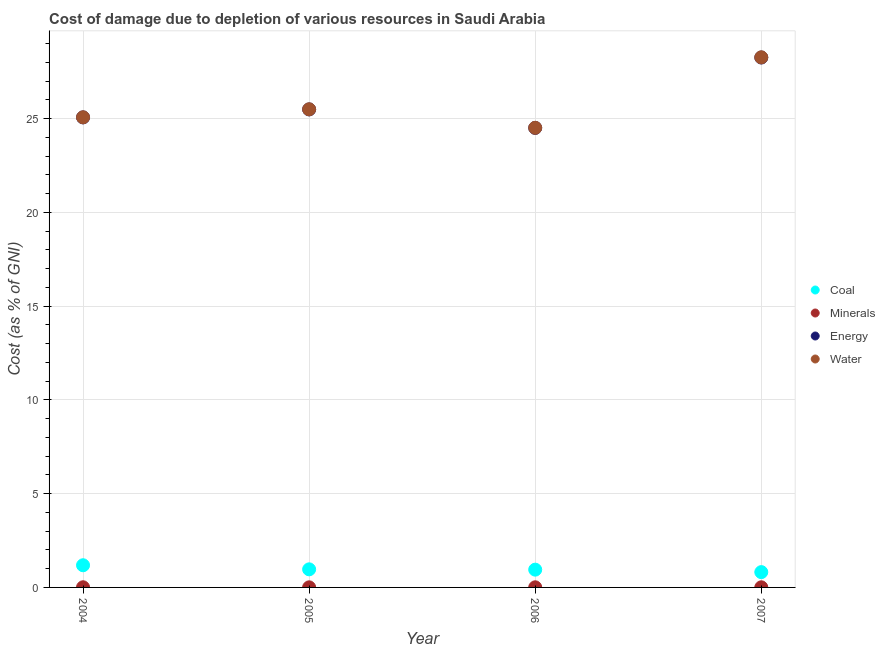How many different coloured dotlines are there?
Your answer should be very brief. 4. What is the cost of damage due to depletion of energy in 2005?
Provide a succinct answer. 25.49. Across all years, what is the maximum cost of damage due to depletion of coal?
Offer a terse response. 1.18. Across all years, what is the minimum cost of damage due to depletion of water?
Make the answer very short. 24.51. What is the total cost of damage due to depletion of minerals in the graph?
Your answer should be very brief. 0.03. What is the difference between the cost of damage due to depletion of minerals in 2006 and that in 2007?
Offer a terse response. 0. What is the difference between the cost of damage due to depletion of minerals in 2006 and the cost of damage due to depletion of energy in 2005?
Provide a short and direct response. -25.48. What is the average cost of damage due to depletion of minerals per year?
Provide a succinct answer. 0.01. In the year 2004, what is the difference between the cost of damage due to depletion of coal and cost of damage due to depletion of minerals?
Provide a short and direct response. 1.17. What is the ratio of the cost of damage due to depletion of water in 2004 to that in 2005?
Ensure brevity in your answer.  0.98. Is the cost of damage due to depletion of energy in 2005 less than that in 2006?
Provide a short and direct response. No. What is the difference between the highest and the second highest cost of damage due to depletion of water?
Provide a succinct answer. 2.77. What is the difference between the highest and the lowest cost of damage due to depletion of water?
Your answer should be very brief. 3.76. Is the sum of the cost of damage due to depletion of energy in 2005 and 2006 greater than the maximum cost of damage due to depletion of coal across all years?
Ensure brevity in your answer.  Yes. Is it the case that in every year, the sum of the cost of damage due to depletion of water and cost of damage due to depletion of minerals is greater than the sum of cost of damage due to depletion of coal and cost of damage due to depletion of energy?
Provide a short and direct response. Yes. Is the cost of damage due to depletion of coal strictly greater than the cost of damage due to depletion of energy over the years?
Make the answer very short. No. Is the cost of damage due to depletion of energy strictly less than the cost of damage due to depletion of minerals over the years?
Offer a terse response. No. Does the graph contain grids?
Provide a short and direct response. Yes. Where does the legend appear in the graph?
Make the answer very short. Center right. How are the legend labels stacked?
Your answer should be compact. Vertical. What is the title of the graph?
Keep it short and to the point. Cost of damage due to depletion of various resources in Saudi Arabia . Does "Offering training" appear as one of the legend labels in the graph?
Provide a succinct answer. No. What is the label or title of the Y-axis?
Offer a very short reply. Cost (as % of GNI). What is the Cost (as % of GNI) in Coal in 2004?
Offer a terse response. 1.18. What is the Cost (as % of GNI) of Minerals in 2004?
Provide a succinct answer. 0.01. What is the Cost (as % of GNI) of Energy in 2004?
Your answer should be compact. 25.06. What is the Cost (as % of GNI) in Water in 2004?
Ensure brevity in your answer.  25.06. What is the Cost (as % of GNI) of Coal in 2005?
Your answer should be compact. 0.96. What is the Cost (as % of GNI) in Minerals in 2005?
Provide a short and direct response. 0. What is the Cost (as % of GNI) in Energy in 2005?
Your answer should be compact. 25.49. What is the Cost (as % of GNI) of Water in 2005?
Provide a short and direct response. 25.49. What is the Cost (as % of GNI) in Coal in 2006?
Offer a very short reply. 0.95. What is the Cost (as % of GNI) of Minerals in 2006?
Your response must be concise. 0.01. What is the Cost (as % of GNI) in Energy in 2006?
Your answer should be compact. 24.5. What is the Cost (as % of GNI) of Water in 2006?
Provide a succinct answer. 24.51. What is the Cost (as % of GNI) of Coal in 2007?
Make the answer very short. 0.82. What is the Cost (as % of GNI) of Minerals in 2007?
Provide a succinct answer. 0.01. What is the Cost (as % of GNI) of Energy in 2007?
Your answer should be compact. 28.25. What is the Cost (as % of GNI) of Water in 2007?
Ensure brevity in your answer.  28.26. Across all years, what is the maximum Cost (as % of GNI) of Coal?
Offer a terse response. 1.18. Across all years, what is the maximum Cost (as % of GNI) of Minerals?
Your answer should be very brief. 0.01. Across all years, what is the maximum Cost (as % of GNI) of Energy?
Provide a succinct answer. 28.25. Across all years, what is the maximum Cost (as % of GNI) in Water?
Your answer should be very brief. 28.26. Across all years, what is the minimum Cost (as % of GNI) of Coal?
Give a very brief answer. 0.82. Across all years, what is the minimum Cost (as % of GNI) in Minerals?
Offer a very short reply. 0. Across all years, what is the minimum Cost (as % of GNI) of Energy?
Offer a terse response. 24.5. Across all years, what is the minimum Cost (as % of GNI) in Water?
Make the answer very short. 24.51. What is the total Cost (as % of GNI) in Coal in the graph?
Provide a succinct answer. 3.91. What is the total Cost (as % of GNI) of Minerals in the graph?
Your response must be concise. 0.03. What is the total Cost (as % of GNI) in Energy in the graph?
Your answer should be very brief. 103.3. What is the total Cost (as % of GNI) of Water in the graph?
Offer a terse response. 103.32. What is the difference between the Cost (as % of GNI) of Coal in 2004 and that in 2005?
Provide a succinct answer. 0.22. What is the difference between the Cost (as % of GNI) of Minerals in 2004 and that in 2005?
Offer a terse response. 0. What is the difference between the Cost (as % of GNI) of Energy in 2004 and that in 2005?
Provide a short and direct response. -0.43. What is the difference between the Cost (as % of GNI) of Water in 2004 and that in 2005?
Offer a terse response. -0.43. What is the difference between the Cost (as % of GNI) in Coal in 2004 and that in 2006?
Your response must be concise. 0.23. What is the difference between the Cost (as % of GNI) of Minerals in 2004 and that in 2006?
Make the answer very short. 0. What is the difference between the Cost (as % of GNI) of Energy in 2004 and that in 2006?
Offer a terse response. 0.56. What is the difference between the Cost (as % of GNI) in Water in 2004 and that in 2006?
Give a very brief answer. 0.56. What is the difference between the Cost (as % of GNI) in Coal in 2004 and that in 2007?
Ensure brevity in your answer.  0.37. What is the difference between the Cost (as % of GNI) in Minerals in 2004 and that in 2007?
Your response must be concise. 0. What is the difference between the Cost (as % of GNI) of Energy in 2004 and that in 2007?
Your answer should be compact. -3.19. What is the difference between the Cost (as % of GNI) of Water in 2004 and that in 2007?
Provide a succinct answer. -3.2. What is the difference between the Cost (as % of GNI) in Coal in 2005 and that in 2006?
Give a very brief answer. 0.02. What is the difference between the Cost (as % of GNI) in Minerals in 2005 and that in 2006?
Give a very brief answer. -0. What is the difference between the Cost (as % of GNI) in Energy in 2005 and that in 2006?
Provide a short and direct response. 0.99. What is the difference between the Cost (as % of GNI) of Water in 2005 and that in 2006?
Offer a terse response. 0.99. What is the difference between the Cost (as % of GNI) of Coal in 2005 and that in 2007?
Offer a very short reply. 0.15. What is the difference between the Cost (as % of GNI) of Minerals in 2005 and that in 2007?
Your answer should be very brief. -0. What is the difference between the Cost (as % of GNI) in Energy in 2005 and that in 2007?
Provide a short and direct response. -2.77. What is the difference between the Cost (as % of GNI) of Water in 2005 and that in 2007?
Your answer should be very brief. -2.77. What is the difference between the Cost (as % of GNI) in Coal in 2006 and that in 2007?
Provide a succinct answer. 0.13. What is the difference between the Cost (as % of GNI) in Energy in 2006 and that in 2007?
Give a very brief answer. -3.75. What is the difference between the Cost (as % of GNI) of Water in 2006 and that in 2007?
Ensure brevity in your answer.  -3.76. What is the difference between the Cost (as % of GNI) in Coal in 2004 and the Cost (as % of GNI) in Minerals in 2005?
Keep it short and to the point. 1.18. What is the difference between the Cost (as % of GNI) in Coal in 2004 and the Cost (as % of GNI) in Energy in 2005?
Offer a very short reply. -24.3. What is the difference between the Cost (as % of GNI) of Coal in 2004 and the Cost (as % of GNI) of Water in 2005?
Provide a succinct answer. -24.31. What is the difference between the Cost (as % of GNI) in Minerals in 2004 and the Cost (as % of GNI) in Energy in 2005?
Make the answer very short. -25.48. What is the difference between the Cost (as % of GNI) in Minerals in 2004 and the Cost (as % of GNI) in Water in 2005?
Your answer should be compact. -25.48. What is the difference between the Cost (as % of GNI) of Energy in 2004 and the Cost (as % of GNI) of Water in 2005?
Offer a very short reply. -0.43. What is the difference between the Cost (as % of GNI) in Coal in 2004 and the Cost (as % of GNI) in Minerals in 2006?
Offer a very short reply. 1.18. What is the difference between the Cost (as % of GNI) of Coal in 2004 and the Cost (as % of GNI) of Energy in 2006?
Your response must be concise. -23.32. What is the difference between the Cost (as % of GNI) of Coal in 2004 and the Cost (as % of GNI) of Water in 2006?
Make the answer very short. -23.32. What is the difference between the Cost (as % of GNI) of Minerals in 2004 and the Cost (as % of GNI) of Energy in 2006?
Your answer should be compact. -24.49. What is the difference between the Cost (as % of GNI) of Minerals in 2004 and the Cost (as % of GNI) of Water in 2006?
Give a very brief answer. -24.5. What is the difference between the Cost (as % of GNI) of Energy in 2004 and the Cost (as % of GNI) of Water in 2006?
Your answer should be very brief. 0.55. What is the difference between the Cost (as % of GNI) in Coal in 2004 and the Cost (as % of GNI) in Minerals in 2007?
Give a very brief answer. 1.18. What is the difference between the Cost (as % of GNI) of Coal in 2004 and the Cost (as % of GNI) of Energy in 2007?
Offer a terse response. -27.07. What is the difference between the Cost (as % of GNI) of Coal in 2004 and the Cost (as % of GNI) of Water in 2007?
Provide a succinct answer. -27.08. What is the difference between the Cost (as % of GNI) of Minerals in 2004 and the Cost (as % of GNI) of Energy in 2007?
Your answer should be very brief. -28.24. What is the difference between the Cost (as % of GNI) of Minerals in 2004 and the Cost (as % of GNI) of Water in 2007?
Keep it short and to the point. -28.25. What is the difference between the Cost (as % of GNI) of Energy in 2004 and the Cost (as % of GNI) of Water in 2007?
Make the answer very short. -3.2. What is the difference between the Cost (as % of GNI) of Coal in 2005 and the Cost (as % of GNI) of Minerals in 2006?
Provide a succinct answer. 0.96. What is the difference between the Cost (as % of GNI) in Coal in 2005 and the Cost (as % of GNI) in Energy in 2006?
Your answer should be compact. -23.54. What is the difference between the Cost (as % of GNI) in Coal in 2005 and the Cost (as % of GNI) in Water in 2006?
Your response must be concise. -23.54. What is the difference between the Cost (as % of GNI) in Minerals in 2005 and the Cost (as % of GNI) in Energy in 2006?
Provide a short and direct response. -24.49. What is the difference between the Cost (as % of GNI) in Minerals in 2005 and the Cost (as % of GNI) in Water in 2006?
Offer a very short reply. -24.5. What is the difference between the Cost (as % of GNI) of Energy in 2005 and the Cost (as % of GNI) of Water in 2006?
Offer a terse response. 0.98. What is the difference between the Cost (as % of GNI) of Coal in 2005 and the Cost (as % of GNI) of Minerals in 2007?
Offer a terse response. 0.96. What is the difference between the Cost (as % of GNI) of Coal in 2005 and the Cost (as % of GNI) of Energy in 2007?
Your answer should be very brief. -27.29. What is the difference between the Cost (as % of GNI) in Coal in 2005 and the Cost (as % of GNI) in Water in 2007?
Provide a short and direct response. -27.3. What is the difference between the Cost (as % of GNI) in Minerals in 2005 and the Cost (as % of GNI) in Energy in 2007?
Ensure brevity in your answer.  -28.25. What is the difference between the Cost (as % of GNI) in Minerals in 2005 and the Cost (as % of GNI) in Water in 2007?
Make the answer very short. -28.26. What is the difference between the Cost (as % of GNI) of Energy in 2005 and the Cost (as % of GNI) of Water in 2007?
Make the answer very short. -2.78. What is the difference between the Cost (as % of GNI) in Coal in 2006 and the Cost (as % of GNI) in Minerals in 2007?
Provide a succinct answer. 0.94. What is the difference between the Cost (as % of GNI) in Coal in 2006 and the Cost (as % of GNI) in Energy in 2007?
Ensure brevity in your answer.  -27.3. What is the difference between the Cost (as % of GNI) in Coal in 2006 and the Cost (as % of GNI) in Water in 2007?
Make the answer very short. -27.31. What is the difference between the Cost (as % of GNI) in Minerals in 2006 and the Cost (as % of GNI) in Energy in 2007?
Provide a short and direct response. -28.25. What is the difference between the Cost (as % of GNI) in Minerals in 2006 and the Cost (as % of GNI) in Water in 2007?
Make the answer very short. -28.26. What is the difference between the Cost (as % of GNI) of Energy in 2006 and the Cost (as % of GNI) of Water in 2007?
Provide a succinct answer. -3.76. What is the average Cost (as % of GNI) of Coal per year?
Make the answer very short. 0.98. What is the average Cost (as % of GNI) of Minerals per year?
Provide a succinct answer. 0.01. What is the average Cost (as % of GNI) of Energy per year?
Your answer should be very brief. 25.82. What is the average Cost (as % of GNI) in Water per year?
Offer a very short reply. 25.83. In the year 2004, what is the difference between the Cost (as % of GNI) of Coal and Cost (as % of GNI) of Minerals?
Offer a terse response. 1.17. In the year 2004, what is the difference between the Cost (as % of GNI) in Coal and Cost (as % of GNI) in Energy?
Your answer should be very brief. -23.88. In the year 2004, what is the difference between the Cost (as % of GNI) of Coal and Cost (as % of GNI) of Water?
Offer a terse response. -23.88. In the year 2004, what is the difference between the Cost (as % of GNI) of Minerals and Cost (as % of GNI) of Energy?
Your answer should be compact. -25.05. In the year 2004, what is the difference between the Cost (as % of GNI) in Minerals and Cost (as % of GNI) in Water?
Provide a short and direct response. -25.06. In the year 2004, what is the difference between the Cost (as % of GNI) of Energy and Cost (as % of GNI) of Water?
Make the answer very short. -0. In the year 2005, what is the difference between the Cost (as % of GNI) of Coal and Cost (as % of GNI) of Minerals?
Ensure brevity in your answer.  0.96. In the year 2005, what is the difference between the Cost (as % of GNI) in Coal and Cost (as % of GNI) in Energy?
Your response must be concise. -24.52. In the year 2005, what is the difference between the Cost (as % of GNI) of Coal and Cost (as % of GNI) of Water?
Give a very brief answer. -24.53. In the year 2005, what is the difference between the Cost (as % of GNI) in Minerals and Cost (as % of GNI) in Energy?
Your answer should be very brief. -25.48. In the year 2005, what is the difference between the Cost (as % of GNI) of Minerals and Cost (as % of GNI) of Water?
Your answer should be very brief. -25.49. In the year 2005, what is the difference between the Cost (as % of GNI) of Energy and Cost (as % of GNI) of Water?
Provide a succinct answer. -0.01. In the year 2006, what is the difference between the Cost (as % of GNI) in Coal and Cost (as % of GNI) in Minerals?
Give a very brief answer. 0.94. In the year 2006, what is the difference between the Cost (as % of GNI) in Coal and Cost (as % of GNI) in Energy?
Offer a very short reply. -23.55. In the year 2006, what is the difference between the Cost (as % of GNI) in Coal and Cost (as % of GNI) in Water?
Make the answer very short. -23.56. In the year 2006, what is the difference between the Cost (as % of GNI) in Minerals and Cost (as % of GNI) in Energy?
Your answer should be compact. -24.49. In the year 2006, what is the difference between the Cost (as % of GNI) in Minerals and Cost (as % of GNI) in Water?
Provide a short and direct response. -24.5. In the year 2006, what is the difference between the Cost (as % of GNI) of Energy and Cost (as % of GNI) of Water?
Make the answer very short. -0.01. In the year 2007, what is the difference between the Cost (as % of GNI) of Coal and Cost (as % of GNI) of Minerals?
Offer a very short reply. 0.81. In the year 2007, what is the difference between the Cost (as % of GNI) of Coal and Cost (as % of GNI) of Energy?
Your response must be concise. -27.44. In the year 2007, what is the difference between the Cost (as % of GNI) in Coal and Cost (as % of GNI) in Water?
Offer a very short reply. -27.45. In the year 2007, what is the difference between the Cost (as % of GNI) in Minerals and Cost (as % of GNI) in Energy?
Your answer should be compact. -28.25. In the year 2007, what is the difference between the Cost (as % of GNI) in Minerals and Cost (as % of GNI) in Water?
Your answer should be compact. -28.26. In the year 2007, what is the difference between the Cost (as % of GNI) of Energy and Cost (as % of GNI) of Water?
Your response must be concise. -0.01. What is the ratio of the Cost (as % of GNI) of Coal in 2004 to that in 2005?
Give a very brief answer. 1.23. What is the ratio of the Cost (as % of GNI) of Minerals in 2004 to that in 2005?
Offer a terse response. 1.72. What is the ratio of the Cost (as % of GNI) of Energy in 2004 to that in 2005?
Your answer should be compact. 0.98. What is the ratio of the Cost (as % of GNI) in Water in 2004 to that in 2005?
Keep it short and to the point. 0.98. What is the ratio of the Cost (as % of GNI) in Coal in 2004 to that in 2006?
Provide a short and direct response. 1.25. What is the ratio of the Cost (as % of GNI) of Minerals in 2004 to that in 2006?
Your response must be concise. 1.24. What is the ratio of the Cost (as % of GNI) in Energy in 2004 to that in 2006?
Offer a very short reply. 1.02. What is the ratio of the Cost (as % of GNI) of Water in 2004 to that in 2006?
Offer a very short reply. 1.02. What is the ratio of the Cost (as % of GNI) of Coal in 2004 to that in 2007?
Ensure brevity in your answer.  1.45. What is the ratio of the Cost (as % of GNI) of Minerals in 2004 to that in 2007?
Ensure brevity in your answer.  1.3. What is the ratio of the Cost (as % of GNI) in Energy in 2004 to that in 2007?
Give a very brief answer. 0.89. What is the ratio of the Cost (as % of GNI) of Water in 2004 to that in 2007?
Your answer should be very brief. 0.89. What is the ratio of the Cost (as % of GNI) in Coal in 2005 to that in 2006?
Provide a short and direct response. 1.02. What is the ratio of the Cost (as % of GNI) of Minerals in 2005 to that in 2006?
Your answer should be very brief. 0.72. What is the ratio of the Cost (as % of GNI) in Energy in 2005 to that in 2006?
Keep it short and to the point. 1.04. What is the ratio of the Cost (as % of GNI) of Water in 2005 to that in 2006?
Offer a very short reply. 1.04. What is the ratio of the Cost (as % of GNI) of Coal in 2005 to that in 2007?
Give a very brief answer. 1.18. What is the ratio of the Cost (as % of GNI) of Minerals in 2005 to that in 2007?
Provide a succinct answer. 0.76. What is the ratio of the Cost (as % of GNI) in Energy in 2005 to that in 2007?
Your answer should be very brief. 0.9. What is the ratio of the Cost (as % of GNI) of Water in 2005 to that in 2007?
Provide a succinct answer. 0.9. What is the ratio of the Cost (as % of GNI) in Coal in 2006 to that in 2007?
Your answer should be very brief. 1.16. What is the ratio of the Cost (as % of GNI) in Minerals in 2006 to that in 2007?
Your answer should be very brief. 1.05. What is the ratio of the Cost (as % of GNI) in Energy in 2006 to that in 2007?
Your answer should be compact. 0.87. What is the ratio of the Cost (as % of GNI) of Water in 2006 to that in 2007?
Provide a short and direct response. 0.87. What is the difference between the highest and the second highest Cost (as % of GNI) in Coal?
Provide a succinct answer. 0.22. What is the difference between the highest and the second highest Cost (as % of GNI) in Minerals?
Provide a succinct answer. 0. What is the difference between the highest and the second highest Cost (as % of GNI) in Energy?
Ensure brevity in your answer.  2.77. What is the difference between the highest and the second highest Cost (as % of GNI) of Water?
Provide a succinct answer. 2.77. What is the difference between the highest and the lowest Cost (as % of GNI) of Coal?
Give a very brief answer. 0.37. What is the difference between the highest and the lowest Cost (as % of GNI) of Minerals?
Provide a short and direct response. 0. What is the difference between the highest and the lowest Cost (as % of GNI) of Energy?
Give a very brief answer. 3.75. What is the difference between the highest and the lowest Cost (as % of GNI) of Water?
Ensure brevity in your answer.  3.76. 